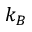Convert formula to latex. <formula><loc_0><loc_0><loc_500><loc_500>k _ { B }</formula> 